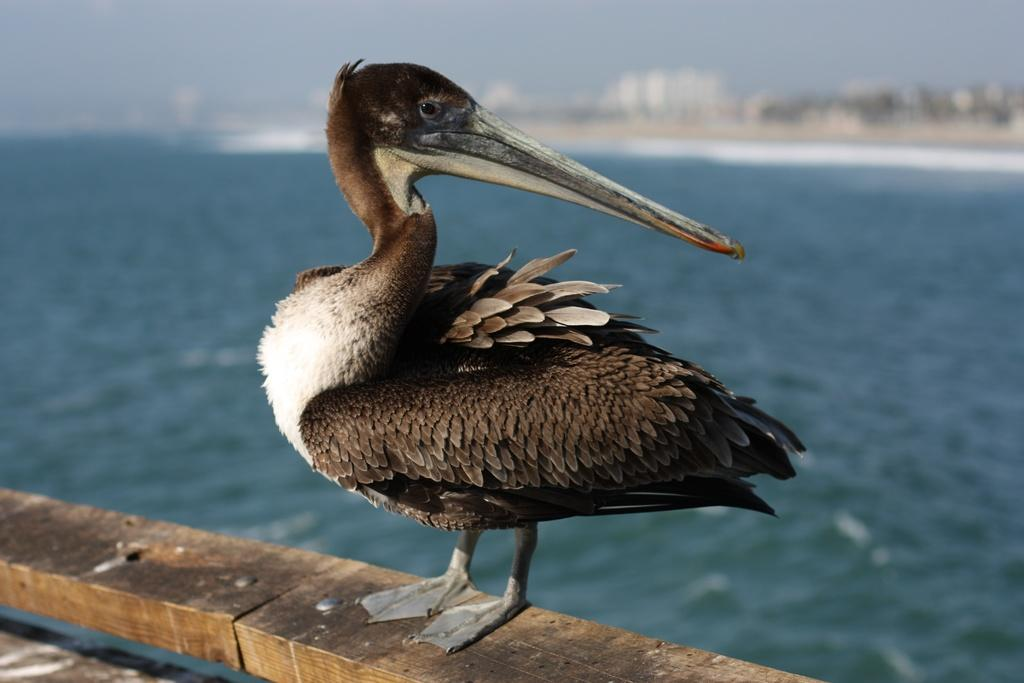What type of bird is in the image? There is a brown pelican in the image. What is the brown pelican standing on? The brown pelican is on a wooden surface. What can be seen in the distance behind the pelican? There is water and buildings visible in the background of the image. Is the brown pelican driving a car in the image? No, the brown pelican is not driving a car in the image; it is standing on a wooden surface. 